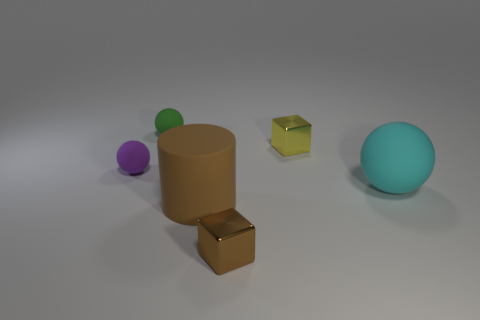There is a object that is the same color as the large cylinder; what is its shape?
Provide a succinct answer. Cube. Are there any matte objects behind the rubber object left of the tiny sphere behind the tiny purple matte sphere?
Your response must be concise. Yes. Does the purple sphere have the same size as the brown cube?
Your response must be concise. Yes. Are there the same number of small blocks to the left of the purple sphere and spheres in front of the small yellow block?
Provide a short and direct response. No. The small shiny object that is left of the tiny yellow shiny object has what shape?
Offer a very short reply. Cube. There is a brown metal thing that is the same size as the purple matte thing; what is its shape?
Give a very brief answer. Cube. What is the color of the small thing in front of the big object in front of the ball on the right side of the tiny yellow cube?
Ensure brevity in your answer.  Brown. Do the small yellow shiny thing and the brown metal thing have the same shape?
Your answer should be very brief. Yes. Are there an equal number of cyan rubber objects that are behind the small purple rubber ball and cubes?
Ensure brevity in your answer.  No. How many other objects are there of the same material as the big ball?
Keep it short and to the point. 3. 